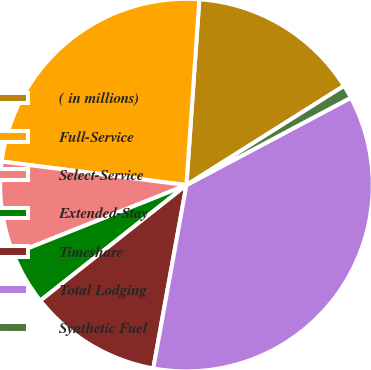<chart> <loc_0><loc_0><loc_500><loc_500><pie_chart><fcel>( in millions)<fcel>Full-Service<fcel>Select-Service<fcel>Extended-Stay<fcel>Timeshare<fcel>Total Lodging<fcel>Synthetic Fuel<nl><fcel>14.95%<fcel>24.08%<fcel>8.06%<fcel>4.61%<fcel>11.5%<fcel>35.62%<fcel>1.17%<nl></chart> 